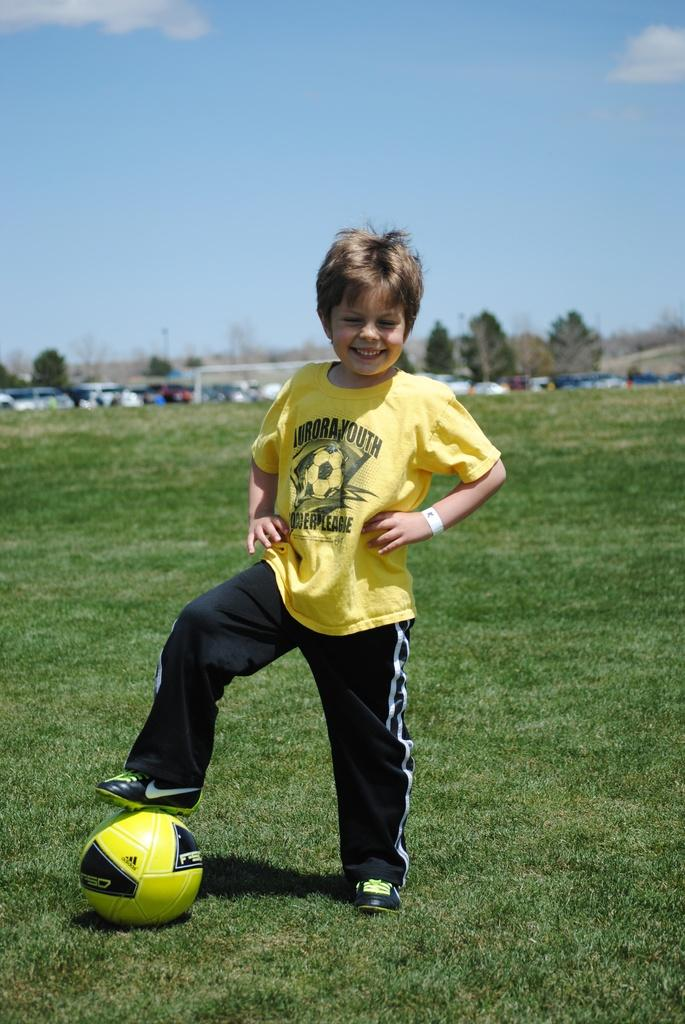<image>
Relay a brief, clear account of the picture shown. A boy wearing Aurora youth shirt has one of his feet on top of a soccer ball. 